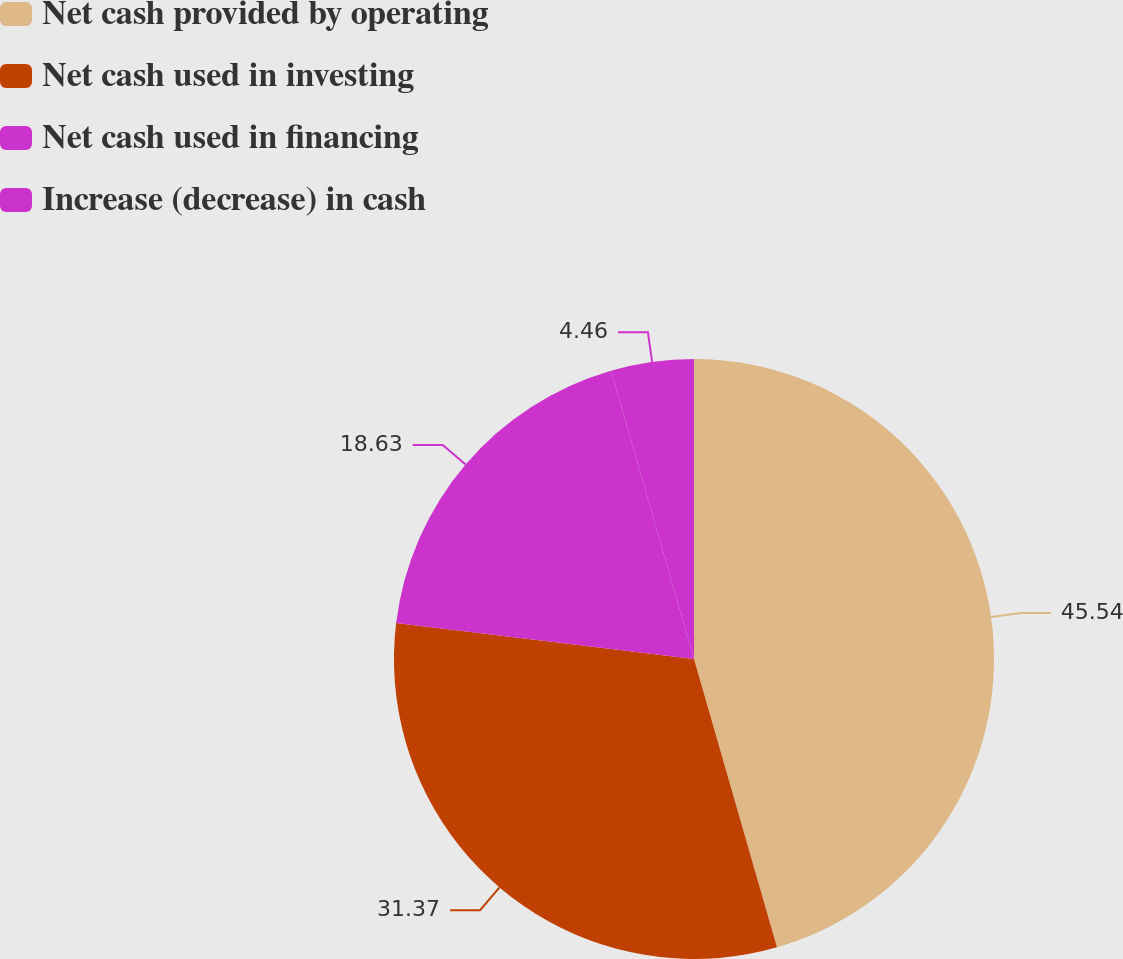Convert chart to OTSL. <chart><loc_0><loc_0><loc_500><loc_500><pie_chart><fcel>Net cash provided by operating<fcel>Net cash used in investing<fcel>Net cash used in financing<fcel>Increase (decrease) in cash<nl><fcel>45.54%<fcel>31.37%<fcel>18.63%<fcel>4.46%<nl></chart> 